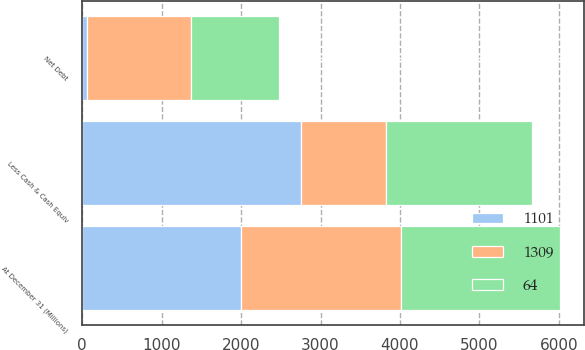Convert chart to OTSL. <chart><loc_0><loc_0><loc_500><loc_500><stacked_bar_chart><ecel><fcel>At December 31 (Millions)<fcel>Less Cash & Cash Equiv<fcel>Net Debt<nl><fcel>1309<fcel>2005<fcel>1072<fcel>1309<nl><fcel>1101<fcel>2004<fcel>2757<fcel>64<nl><fcel>64<fcel>2003<fcel>1836<fcel>1101<nl></chart> 